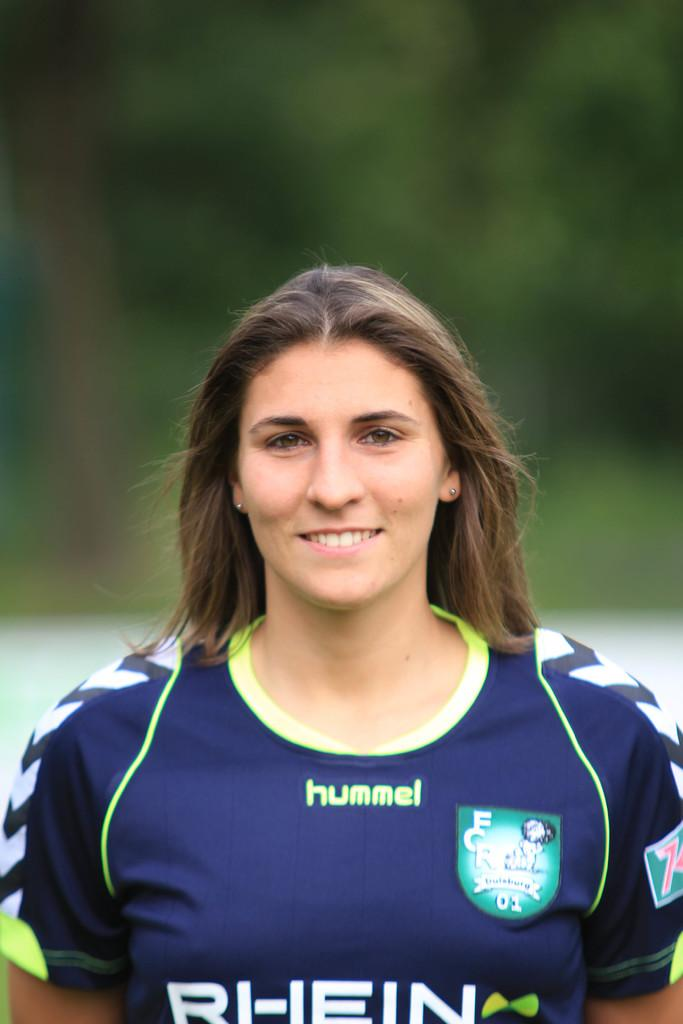<image>
Share a concise interpretation of the image provided. A young lady wears a blue sports tops with hummel and Rhein on the front. 